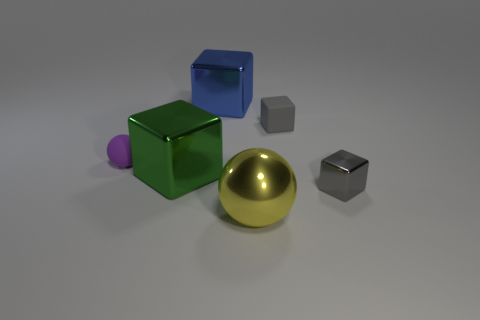Subtract all gray spheres. How many gray cubes are left? 2 Subtract all green blocks. How many blocks are left? 3 Add 3 small objects. How many objects exist? 9 Subtract all big green shiny cubes. How many cubes are left? 3 Subtract all yellow cubes. Subtract all gray cylinders. How many cubes are left? 4 Add 6 large green metallic cubes. How many large green metallic cubes exist? 7 Subtract 0 cyan spheres. How many objects are left? 6 Subtract all blocks. How many objects are left? 2 Subtract all small red metallic objects. Subtract all big objects. How many objects are left? 3 Add 1 green shiny cubes. How many green shiny cubes are left? 2 